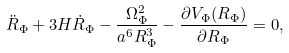Convert formula to latex. <formula><loc_0><loc_0><loc_500><loc_500>\ddot { R } _ { \Phi } + 3 H \dot { R } _ { \Phi } - \frac { \Omega _ { \Phi } ^ { 2 } } { a ^ { 6 } R _ { \Phi } ^ { 3 } } - \frac { \partial V _ { \Phi } ( R _ { \Phi } ) } { \partial R _ { \Phi } } = 0 ,</formula> 